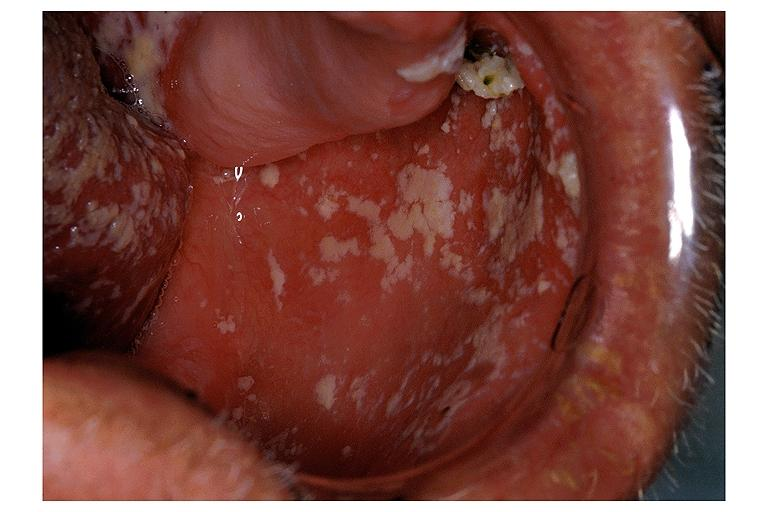s oral present?
Answer the question using a single word or phrase. Yes 